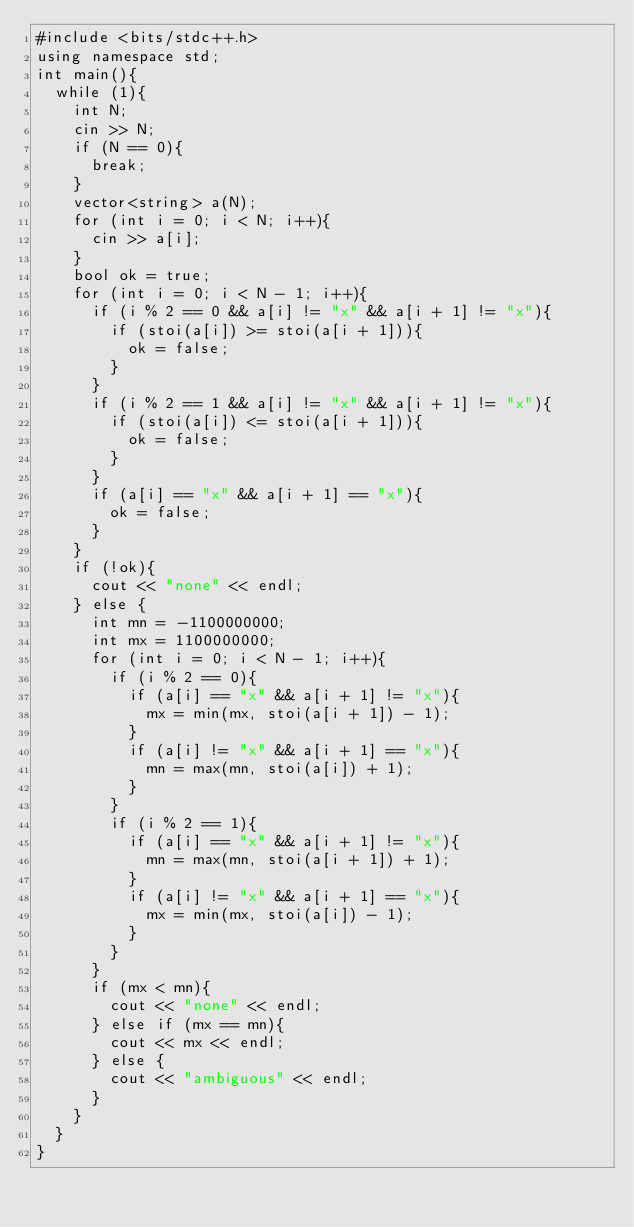<code> <loc_0><loc_0><loc_500><loc_500><_C++_>#include <bits/stdc++.h>
using namespace std;
int main(){
  while (1){
    int N;
    cin >> N;
    if (N == 0){
      break;
    }
    vector<string> a(N);
    for (int i = 0; i < N; i++){
      cin >> a[i];
    }
    bool ok = true;
    for (int i = 0; i < N - 1; i++){
      if (i % 2 == 0 && a[i] != "x" && a[i + 1] != "x"){
        if (stoi(a[i]) >= stoi(a[i + 1])){
          ok = false;
        }
      }
      if (i % 2 == 1 && a[i] != "x" && a[i + 1] != "x"){
        if (stoi(a[i]) <= stoi(a[i + 1])){
          ok = false;
        }
      }
      if (a[i] == "x" && a[i + 1] == "x"){
        ok = false;
      }
    }
    if (!ok){
      cout << "none" << endl;
    } else {
      int mn = -1100000000;
      int mx = 1100000000;
      for (int i = 0; i < N - 1; i++){
        if (i % 2 == 0){
          if (a[i] == "x" && a[i + 1] != "x"){
            mx = min(mx, stoi(a[i + 1]) - 1);
          }
          if (a[i] != "x" && a[i + 1] == "x"){
            mn = max(mn, stoi(a[i]) + 1);
          }
        }
        if (i % 2 == 1){
          if (a[i] == "x" && a[i + 1] != "x"){
            mn = max(mn, stoi(a[i + 1]) + 1);
          }
          if (a[i] != "x" && a[i + 1] == "x"){
            mx = min(mx, stoi(a[i]) - 1);
          }
        }
      }
      if (mx < mn){
        cout << "none" << endl;
      } else if (mx == mn){
        cout << mx << endl;
      } else {
        cout << "ambiguous" << endl;
      }
    }
  }
}
</code> 